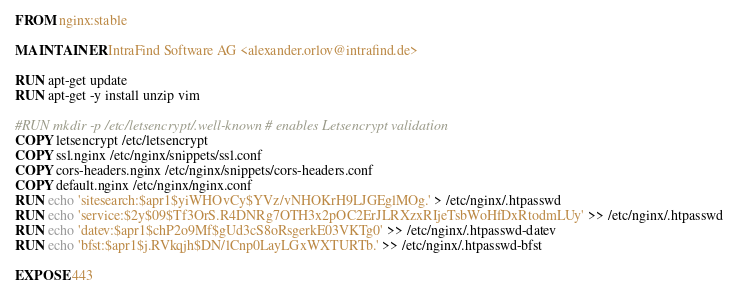Convert code to text. <code><loc_0><loc_0><loc_500><loc_500><_Dockerfile_>FROM nginx:stable

MAINTAINER IntraFind Software AG <alexander.orlov@intrafind.de>

RUN apt-get update
RUN apt-get -y install unzip vim

#RUN mkdir -p /etc/letsencrypt/.well-known # enables Letsencrypt validation
COPY letsencrypt /etc/letsencrypt
COPY ssl.nginx /etc/nginx/snippets/ssl.conf
COPY cors-headers.nginx /etc/nginx/snippets/cors-headers.conf
COPY default.nginx /etc/nginx/nginx.conf
RUN echo 'sitesearch:$apr1$yiWHOvCy$YVz/vNHOKrH9LJGEglMOg.' > /etc/nginx/.htpasswd
RUN echo 'service:$2y$09$Tf3OrS.R4DNRg7OTH3x2pOC2ErJLRXzxRIjeTsbWoHfDxRtodmLUy' >> /etc/nginx/.htpasswd
RUN echo 'datev:$apr1$chP2o9Mf$gUd3cS8oRsgerkE03VKTg0' >> /etc/nginx/.htpasswd-datev
RUN echo 'bfst:$apr1$j.RVkqjh$DN/lCnp0LayLGxWXTURTb.' >> /etc/nginx/.htpasswd-bfst

EXPOSE 443</code> 